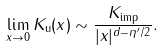Convert formula to latex. <formula><loc_0><loc_0><loc_500><loc_500>\lim _ { x \rightarrow 0 } K _ { \text {u} } ( x ) \sim \frac { K _ { \text {imp} } } { | x | ^ { d - \eta ^ { \prime } / 2 } } .</formula> 